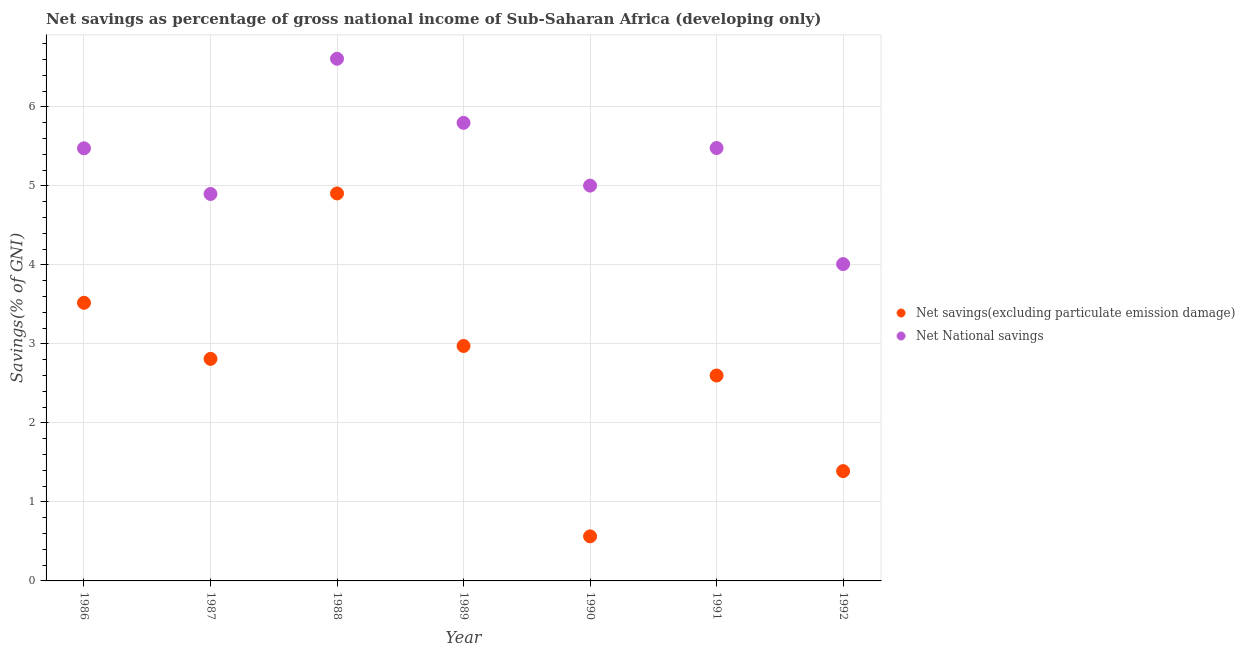Is the number of dotlines equal to the number of legend labels?
Your answer should be compact. Yes. What is the net savings(excluding particulate emission damage) in 1989?
Provide a short and direct response. 2.97. Across all years, what is the maximum net savings(excluding particulate emission damage)?
Offer a terse response. 4.9. Across all years, what is the minimum net national savings?
Your response must be concise. 4.01. In which year was the net national savings maximum?
Offer a terse response. 1988. What is the total net national savings in the graph?
Provide a succinct answer. 37.27. What is the difference between the net national savings in 1991 and that in 1992?
Your answer should be compact. 1.47. What is the difference between the net national savings in 1987 and the net savings(excluding particulate emission damage) in 1988?
Ensure brevity in your answer.  -0.01. What is the average net savings(excluding particulate emission damage) per year?
Make the answer very short. 2.68. In the year 1987, what is the difference between the net national savings and net savings(excluding particulate emission damage)?
Offer a terse response. 2.09. In how many years, is the net savings(excluding particulate emission damage) greater than 2.4 %?
Provide a succinct answer. 5. What is the ratio of the net savings(excluding particulate emission damage) in 1986 to that in 1988?
Your answer should be very brief. 0.72. What is the difference between the highest and the second highest net national savings?
Offer a very short reply. 0.81. What is the difference between the highest and the lowest net national savings?
Your response must be concise. 2.6. Is the net national savings strictly less than the net savings(excluding particulate emission damage) over the years?
Keep it short and to the point. No. How many dotlines are there?
Your answer should be very brief. 2. How many years are there in the graph?
Your answer should be very brief. 7. Does the graph contain grids?
Your answer should be compact. Yes. Where does the legend appear in the graph?
Offer a terse response. Center right. How many legend labels are there?
Your answer should be very brief. 2. What is the title of the graph?
Provide a succinct answer. Net savings as percentage of gross national income of Sub-Saharan Africa (developing only). Does "Start a business" appear as one of the legend labels in the graph?
Keep it short and to the point. No. What is the label or title of the Y-axis?
Offer a very short reply. Savings(% of GNI). What is the Savings(% of GNI) in Net savings(excluding particulate emission damage) in 1986?
Your answer should be compact. 3.52. What is the Savings(% of GNI) of Net National savings in 1986?
Keep it short and to the point. 5.47. What is the Savings(% of GNI) in Net savings(excluding particulate emission damage) in 1987?
Make the answer very short. 2.81. What is the Savings(% of GNI) of Net National savings in 1987?
Make the answer very short. 4.9. What is the Savings(% of GNI) of Net savings(excluding particulate emission damage) in 1988?
Your answer should be very brief. 4.9. What is the Savings(% of GNI) of Net National savings in 1988?
Give a very brief answer. 6.61. What is the Savings(% of GNI) in Net savings(excluding particulate emission damage) in 1989?
Offer a terse response. 2.97. What is the Savings(% of GNI) in Net National savings in 1989?
Your answer should be very brief. 5.8. What is the Savings(% of GNI) of Net savings(excluding particulate emission damage) in 1990?
Your answer should be compact. 0.56. What is the Savings(% of GNI) in Net National savings in 1990?
Keep it short and to the point. 5. What is the Savings(% of GNI) in Net savings(excluding particulate emission damage) in 1991?
Offer a terse response. 2.6. What is the Savings(% of GNI) of Net National savings in 1991?
Give a very brief answer. 5.48. What is the Savings(% of GNI) of Net savings(excluding particulate emission damage) in 1992?
Your response must be concise. 1.39. What is the Savings(% of GNI) in Net National savings in 1992?
Offer a terse response. 4.01. Across all years, what is the maximum Savings(% of GNI) in Net savings(excluding particulate emission damage)?
Provide a succinct answer. 4.9. Across all years, what is the maximum Savings(% of GNI) in Net National savings?
Give a very brief answer. 6.61. Across all years, what is the minimum Savings(% of GNI) in Net savings(excluding particulate emission damage)?
Make the answer very short. 0.56. Across all years, what is the minimum Savings(% of GNI) in Net National savings?
Make the answer very short. 4.01. What is the total Savings(% of GNI) of Net savings(excluding particulate emission damage) in the graph?
Ensure brevity in your answer.  18.76. What is the total Savings(% of GNI) of Net National savings in the graph?
Your response must be concise. 37.27. What is the difference between the Savings(% of GNI) of Net savings(excluding particulate emission damage) in 1986 and that in 1987?
Your answer should be very brief. 0.71. What is the difference between the Savings(% of GNI) in Net National savings in 1986 and that in 1987?
Provide a succinct answer. 0.58. What is the difference between the Savings(% of GNI) of Net savings(excluding particulate emission damage) in 1986 and that in 1988?
Your answer should be very brief. -1.38. What is the difference between the Savings(% of GNI) of Net National savings in 1986 and that in 1988?
Your response must be concise. -1.13. What is the difference between the Savings(% of GNI) of Net savings(excluding particulate emission damage) in 1986 and that in 1989?
Offer a very short reply. 0.55. What is the difference between the Savings(% of GNI) of Net National savings in 1986 and that in 1989?
Provide a short and direct response. -0.32. What is the difference between the Savings(% of GNI) of Net savings(excluding particulate emission damage) in 1986 and that in 1990?
Provide a short and direct response. 2.96. What is the difference between the Savings(% of GNI) in Net National savings in 1986 and that in 1990?
Your answer should be compact. 0.47. What is the difference between the Savings(% of GNI) in Net savings(excluding particulate emission damage) in 1986 and that in 1991?
Provide a succinct answer. 0.92. What is the difference between the Savings(% of GNI) in Net National savings in 1986 and that in 1991?
Offer a terse response. -0. What is the difference between the Savings(% of GNI) of Net savings(excluding particulate emission damage) in 1986 and that in 1992?
Your response must be concise. 2.13. What is the difference between the Savings(% of GNI) in Net National savings in 1986 and that in 1992?
Provide a short and direct response. 1.47. What is the difference between the Savings(% of GNI) in Net savings(excluding particulate emission damage) in 1987 and that in 1988?
Provide a short and direct response. -2.09. What is the difference between the Savings(% of GNI) in Net National savings in 1987 and that in 1988?
Keep it short and to the point. -1.71. What is the difference between the Savings(% of GNI) of Net savings(excluding particulate emission damage) in 1987 and that in 1989?
Provide a succinct answer. -0.16. What is the difference between the Savings(% of GNI) of Net National savings in 1987 and that in 1989?
Make the answer very short. -0.9. What is the difference between the Savings(% of GNI) in Net savings(excluding particulate emission damage) in 1987 and that in 1990?
Provide a succinct answer. 2.25. What is the difference between the Savings(% of GNI) in Net National savings in 1987 and that in 1990?
Provide a succinct answer. -0.11. What is the difference between the Savings(% of GNI) in Net savings(excluding particulate emission damage) in 1987 and that in 1991?
Ensure brevity in your answer.  0.21. What is the difference between the Savings(% of GNI) of Net National savings in 1987 and that in 1991?
Make the answer very short. -0.58. What is the difference between the Savings(% of GNI) in Net savings(excluding particulate emission damage) in 1987 and that in 1992?
Give a very brief answer. 1.42. What is the difference between the Savings(% of GNI) of Net National savings in 1987 and that in 1992?
Your answer should be compact. 0.89. What is the difference between the Savings(% of GNI) in Net savings(excluding particulate emission damage) in 1988 and that in 1989?
Offer a terse response. 1.93. What is the difference between the Savings(% of GNI) in Net National savings in 1988 and that in 1989?
Ensure brevity in your answer.  0.81. What is the difference between the Savings(% of GNI) in Net savings(excluding particulate emission damage) in 1988 and that in 1990?
Your answer should be compact. 4.34. What is the difference between the Savings(% of GNI) in Net National savings in 1988 and that in 1990?
Offer a very short reply. 1.61. What is the difference between the Savings(% of GNI) in Net savings(excluding particulate emission damage) in 1988 and that in 1991?
Your answer should be compact. 2.3. What is the difference between the Savings(% of GNI) in Net National savings in 1988 and that in 1991?
Give a very brief answer. 1.13. What is the difference between the Savings(% of GNI) of Net savings(excluding particulate emission damage) in 1988 and that in 1992?
Your answer should be compact. 3.51. What is the difference between the Savings(% of GNI) of Net National savings in 1988 and that in 1992?
Provide a short and direct response. 2.6. What is the difference between the Savings(% of GNI) in Net savings(excluding particulate emission damage) in 1989 and that in 1990?
Your response must be concise. 2.41. What is the difference between the Savings(% of GNI) in Net National savings in 1989 and that in 1990?
Provide a succinct answer. 0.79. What is the difference between the Savings(% of GNI) in Net savings(excluding particulate emission damage) in 1989 and that in 1991?
Give a very brief answer. 0.37. What is the difference between the Savings(% of GNI) in Net National savings in 1989 and that in 1991?
Your response must be concise. 0.32. What is the difference between the Savings(% of GNI) in Net savings(excluding particulate emission damage) in 1989 and that in 1992?
Offer a very short reply. 1.58. What is the difference between the Savings(% of GNI) of Net National savings in 1989 and that in 1992?
Offer a terse response. 1.79. What is the difference between the Savings(% of GNI) of Net savings(excluding particulate emission damage) in 1990 and that in 1991?
Provide a succinct answer. -2.04. What is the difference between the Savings(% of GNI) in Net National savings in 1990 and that in 1991?
Give a very brief answer. -0.48. What is the difference between the Savings(% of GNI) of Net savings(excluding particulate emission damage) in 1990 and that in 1992?
Keep it short and to the point. -0.83. What is the difference between the Savings(% of GNI) in Net National savings in 1990 and that in 1992?
Provide a succinct answer. 0.99. What is the difference between the Savings(% of GNI) in Net savings(excluding particulate emission damage) in 1991 and that in 1992?
Offer a very short reply. 1.21. What is the difference between the Savings(% of GNI) in Net National savings in 1991 and that in 1992?
Your answer should be compact. 1.47. What is the difference between the Savings(% of GNI) of Net savings(excluding particulate emission damage) in 1986 and the Savings(% of GNI) of Net National savings in 1987?
Give a very brief answer. -1.38. What is the difference between the Savings(% of GNI) in Net savings(excluding particulate emission damage) in 1986 and the Savings(% of GNI) in Net National savings in 1988?
Make the answer very short. -3.09. What is the difference between the Savings(% of GNI) of Net savings(excluding particulate emission damage) in 1986 and the Savings(% of GNI) of Net National savings in 1989?
Your response must be concise. -2.28. What is the difference between the Savings(% of GNI) in Net savings(excluding particulate emission damage) in 1986 and the Savings(% of GNI) in Net National savings in 1990?
Make the answer very short. -1.48. What is the difference between the Savings(% of GNI) of Net savings(excluding particulate emission damage) in 1986 and the Savings(% of GNI) of Net National savings in 1991?
Your answer should be compact. -1.96. What is the difference between the Savings(% of GNI) in Net savings(excluding particulate emission damage) in 1986 and the Savings(% of GNI) in Net National savings in 1992?
Ensure brevity in your answer.  -0.49. What is the difference between the Savings(% of GNI) in Net savings(excluding particulate emission damage) in 1987 and the Savings(% of GNI) in Net National savings in 1988?
Offer a very short reply. -3.8. What is the difference between the Savings(% of GNI) of Net savings(excluding particulate emission damage) in 1987 and the Savings(% of GNI) of Net National savings in 1989?
Provide a succinct answer. -2.99. What is the difference between the Savings(% of GNI) of Net savings(excluding particulate emission damage) in 1987 and the Savings(% of GNI) of Net National savings in 1990?
Provide a short and direct response. -2.19. What is the difference between the Savings(% of GNI) of Net savings(excluding particulate emission damage) in 1987 and the Savings(% of GNI) of Net National savings in 1991?
Your answer should be compact. -2.67. What is the difference between the Savings(% of GNI) in Net savings(excluding particulate emission damage) in 1987 and the Savings(% of GNI) in Net National savings in 1992?
Your answer should be very brief. -1.2. What is the difference between the Savings(% of GNI) in Net savings(excluding particulate emission damage) in 1988 and the Savings(% of GNI) in Net National savings in 1989?
Keep it short and to the point. -0.89. What is the difference between the Savings(% of GNI) of Net savings(excluding particulate emission damage) in 1988 and the Savings(% of GNI) of Net National savings in 1990?
Give a very brief answer. -0.1. What is the difference between the Savings(% of GNI) in Net savings(excluding particulate emission damage) in 1988 and the Savings(% of GNI) in Net National savings in 1991?
Make the answer very short. -0.57. What is the difference between the Savings(% of GNI) of Net savings(excluding particulate emission damage) in 1988 and the Savings(% of GNI) of Net National savings in 1992?
Make the answer very short. 0.89. What is the difference between the Savings(% of GNI) in Net savings(excluding particulate emission damage) in 1989 and the Savings(% of GNI) in Net National savings in 1990?
Give a very brief answer. -2.03. What is the difference between the Savings(% of GNI) of Net savings(excluding particulate emission damage) in 1989 and the Savings(% of GNI) of Net National savings in 1991?
Ensure brevity in your answer.  -2.5. What is the difference between the Savings(% of GNI) in Net savings(excluding particulate emission damage) in 1989 and the Savings(% of GNI) in Net National savings in 1992?
Provide a short and direct response. -1.04. What is the difference between the Savings(% of GNI) in Net savings(excluding particulate emission damage) in 1990 and the Savings(% of GNI) in Net National savings in 1991?
Your answer should be compact. -4.91. What is the difference between the Savings(% of GNI) in Net savings(excluding particulate emission damage) in 1990 and the Savings(% of GNI) in Net National savings in 1992?
Ensure brevity in your answer.  -3.45. What is the difference between the Savings(% of GNI) in Net savings(excluding particulate emission damage) in 1991 and the Savings(% of GNI) in Net National savings in 1992?
Your answer should be very brief. -1.41. What is the average Savings(% of GNI) of Net savings(excluding particulate emission damage) per year?
Offer a terse response. 2.68. What is the average Savings(% of GNI) of Net National savings per year?
Provide a short and direct response. 5.32. In the year 1986, what is the difference between the Savings(% of GNI) in Net savings(excluding particulate emission damage) and Savings(% of GNI) in Net National savings?
Provide a short and direct response. -1.96. In the year 1987, what is the difference between the Savings(% of GNI) in Net savings(excluding particulate emission damage) and Savings(% of GNI) in Net National savings?
Keep it short and to the point. -2.09. In the year 1988, what is the difference between the Savings(% of GNI) in Net savings(excluding particulate emission damage) and Savings(% of GNI) in Net National savings?
Your response must be concise. -1.7. In the year 1989, what is the difference between the Savings(% of GNI) in Net savings(excluding particulate emission damage) and Savings(% of GNI) in Net National savings?
Keep it short and to the point. -2.82. In the year 1990, what is the difference between the Savings(% of GNI) of Net savings(excluding particulate emission damage) and Savings(% of GNI) of Net National savings?
Offer a very short reply. -4.44. In the year 1991, what is the difference between the Savings(% of GNI) in Net savings(excluding particulate emission damage) and Savings(% of GNI) in Net National savings?
Make the answer very short. -2.88. In the year 1992, what is the difference between the Savings(% of GNI) of Net savings(excluding particulate emission damage) and Savings(% of GNI) of Net National savings?
Your answer should be compact. -2.62. What is the ratio of the Savings(% of GNI) of Net savings(excluding particulate emission damage) in 1986 to that in 1987?
Your answer should be very brief. 1.25. What is the ratio of the Savings(% of GNI) of Net National savings in 1986 to that in 1987?
Your answer should be very brief. 1.12. What is the ratio of the Savings(% of GNI) in Net savings(excluding particulate emission damage) in 1986 to that in 1988?
Your answer should be compact. 0.72. What is the ratio of the Savings(% of GNI) of Net National savings in 1986 to that in 1988?
Your response must be concise. 0.83. What is the ratio of the Savings(% of GNI) of Net savings(excluding particulate emission damage) in 1986 to that in 1989?
Your answer should be very brief. 1.18. What is the ratio of the Savings(% of GNI) in Net savings(excluding particulate emission damage) in 1986 to that in 1990?
Ensure brevity in your answer.  6.24. What is the ratio of the Savings(% of GNI) of Net National savings in 1986 to that in 1990?
Provide a short and direct response. 1.09. What is the ratio of the Savings(% of GNI) of Net savings(excluding particulate emission damage) in 1986 to that in 1991?
Ensure brevity in your answer.  1.35. What is the ratio of the Savings(% of GNI) in Net savings(excluding particulate emission damage) in 1986 to that in 1992?
Offer a terse response. 2.53. What is the ratio of the Savings(% of GNI) in Net National savings in 1986 to that in 1992?
Offer a very short reply. 1.37. What is the ratio of the Savings(% of GNI) in Net savings(excluding particulate emission damage) in 1987 to that in 1988?
Your answer should be very brief. 0.57. What is the ratio of the Savings(% of GNI) of Net National savings in 1987 to that in 1988?
Your answer should be very brief. 0.74. What is the ratio of the Savings(% of GNI) of Net savings(excluding particulate emission damage) in 1987 to that in 1989?
Ensure brevity in your answer.  0.94. What is the ratio of the Savings(% of GNI) in Net National savings in 1987 to that in 1989?
Keep it short and to the point. 0.84. What is the ratio of the Savings(% of GNI) in Net savings(excluding particulate emission damage) in 1987 to that in 1990?
Provide a succinct answer. 4.98. What is the ratio of the Savings(% of GNI) of Net National savings in 1987 to that in 1990?
Your answer should be compact. 0.98. What is the ratio of the Savings(% of GNI) of Net savings(excluding particulate emission damage) in 1987 to that in 1991?
Keep it short and to the point. 1.08. What is the ratio of the Savings(% of GNI) in Net National savings in 1987 to that in 1991?
Give a very brief answer. 0.89. What is the ratio of the Savings(% of GNI) in Net savings(excluding particulate emission damage) in 1987 to that in 1992?
Your response must be concise. 2.02. What is the ratio of the Savings(% of GNI) in Net National savings in 1987 to that in 1992?
Give a very brief answer. 1.22. What is the ratio of the Savings(% of GNI) in Net savings(excluding particulate emission damage) in 1988 to that in 1989?
Offer a very short reply. 1.65. What is the ratio of the Savings(% of GNI) of Net National savings in 1988 to that in 1989?
Keep it short and to the point. 1.14. What is the ratio of the Savings(% of GNI) in Net savings(excluding particulate emission damage) in 1988 to that in 1990?
Give a very brief answer. 8.7. What is the ratio of the Savings(% of GNI) of Net National savings in 1988 to that in 1990?
Offer a very short reply. 1.32. What is the ratio of the Savings(% of GNI) in Net savings(excluding particulate emission damage) in 1988 to that in 1991?
Provide a succinct answer. 1.89. What is the ratio of the Savings(% of GNI) of Net National savings in 1988 to that in 1991?
Keep it short and to the point. 1.21. What is the ratio of the Savings(% of GNI) in Net savings(excluding particulate emission damage) in 1988 to that in 1992?
Make the answer very short. 3.53. What is the ratio of the Savings(% of GNI) in Net National savings in 1988 to that in 1992?
Your response must be concise. 1.65. What is the ratio of the Savings(% of GNI) of Net savings(excluding particulate emission damage) in 1989 to that in 1990?
Provide a succinct answer. 5.27. What is the ratio of the Savings(% of GNI) of Net National savings in 1989 to that in 1990?
Ensure brevity in your answer.  1.16. What is the ratio of the Savings(% of GNI) in Net savings(excluding particulate emission damage) in 1989 to that in 1991?
Your response must be concise. 1.14. What is the ratio of the Savings(% of GNI) in Net National savings in 1989 to that in 1991?
Ensure brevity in your answer.  1.06. What is the ratio of the Savings(% of GNI) in Net savings(excluding particulate emission damage) in 1989 to that in 1992?
Offer a terse response. 2.14. What is the ratio of the Savings(% of GNI) in Net National savings in 1989 to that in 1992?
Your answer should be compact. 1.45. What is the ratio of the Savings(% of GNI) in Net savings(excluding particulate emission damage) in 1990 to that in 1991?
Ensure brevity in your answer.  0.22. What is the ratio of the Savings(% of GNI) in Net National savings in 1990 to that in 1991?
Give a very brief answer. 0.91. What is the ratio of the Savings(% of GNI) of Net savings(excluding particulate emission damage) in 1990 to that in 1992?
Ensure brevity in your answer.  0.41. What is the ratio of the Savings(% of GNI) in Net National savings in 1990 to that in 1992?
Provide a short and direct response. 1.25. What is the ratio of the Savings(% of GNI) in Net savings(excluding particulate emission damage) in 1991 to that in 1992?
Make the answer very short. 1.87. What is the ratio of the Savings(% of GNI) of Net National savings in 1991 to that in 1992?
Your answer should be compact. 1.37. What is the difference between the highest and the second highest Savings(% of GNI) of Net savings(excluding particulate emission damage)?
Give a very brief answer. 1.38. What is the difference between the highest and the second highest Savings(% of GNI) of Net National savings?
Give a very brief answer. 0.81. What is the difference between the highest and the lowest Savings(% of GNI) in Net savings(excluding particulate emission damage)?
Your answer should be very brief. 4.34. What is the difference between the highest and the lowest Savings(% of GNI) of Net National savings?
Your response must be concise. 2.6. 